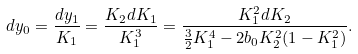<formula> <loc_0><loc_0><loc_500><loc_500>d y _ { 0 } = \frac { d y _ { 1 } } { K _ { 1 } } = \frac { K _ { 2 } d K _ { 1 } } { K _ { 1 } ^ { 3 } } = \frac { K _ { 1 } ^ { 2 } d K _ { 2 } } { \frac { 3 } { 2 } K _ { 1 } ^ { 4 } - 2 b _ { 0 } K ^ { 2 } _ { 2 } ( 1 - K _ { 1 } ^ { 2 } ) } .</formula> 